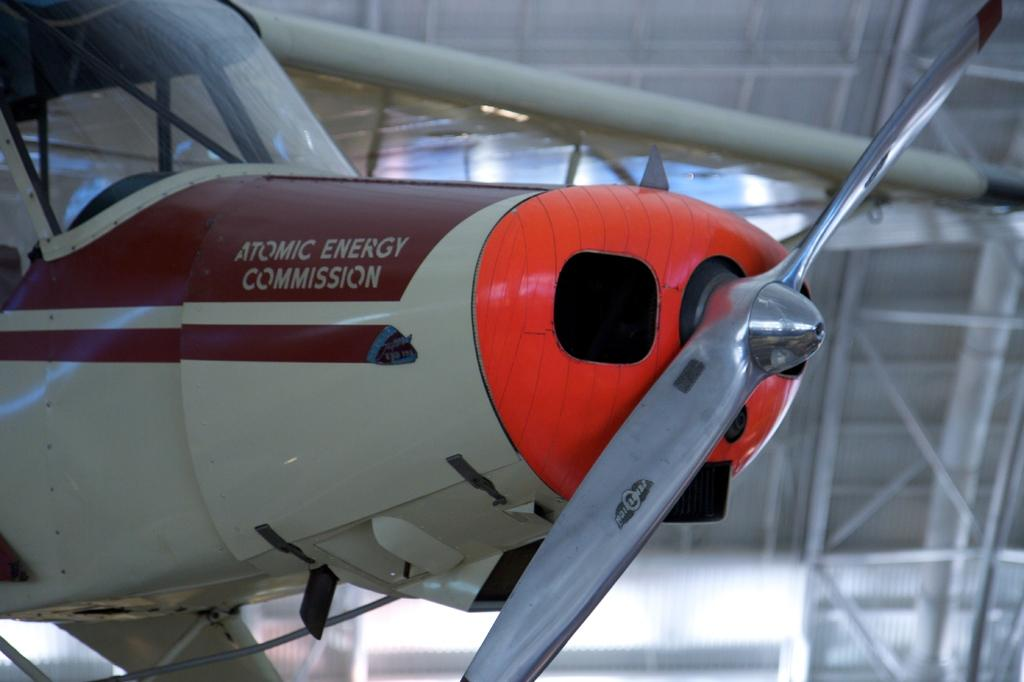What is the main subject of the image? The main subject of the image is an aircraft. What specific features does the aircraft have? The aircraft has a propeller and a wing. Are the wing and propeller attached to the aircraft? Yes, the wing and propeller are attached to the aircraft. What might be located at the front part of the aircraft? The front part of the aircraft may be a cockpit. How would you describe the background of the image? The background of the image appears blurry. How many ice cubes are visible in the image? There are no ice cubes present in the image. What type of roll can be seen being prepared in the image? There is no roll or any food preparation visible in the image. 